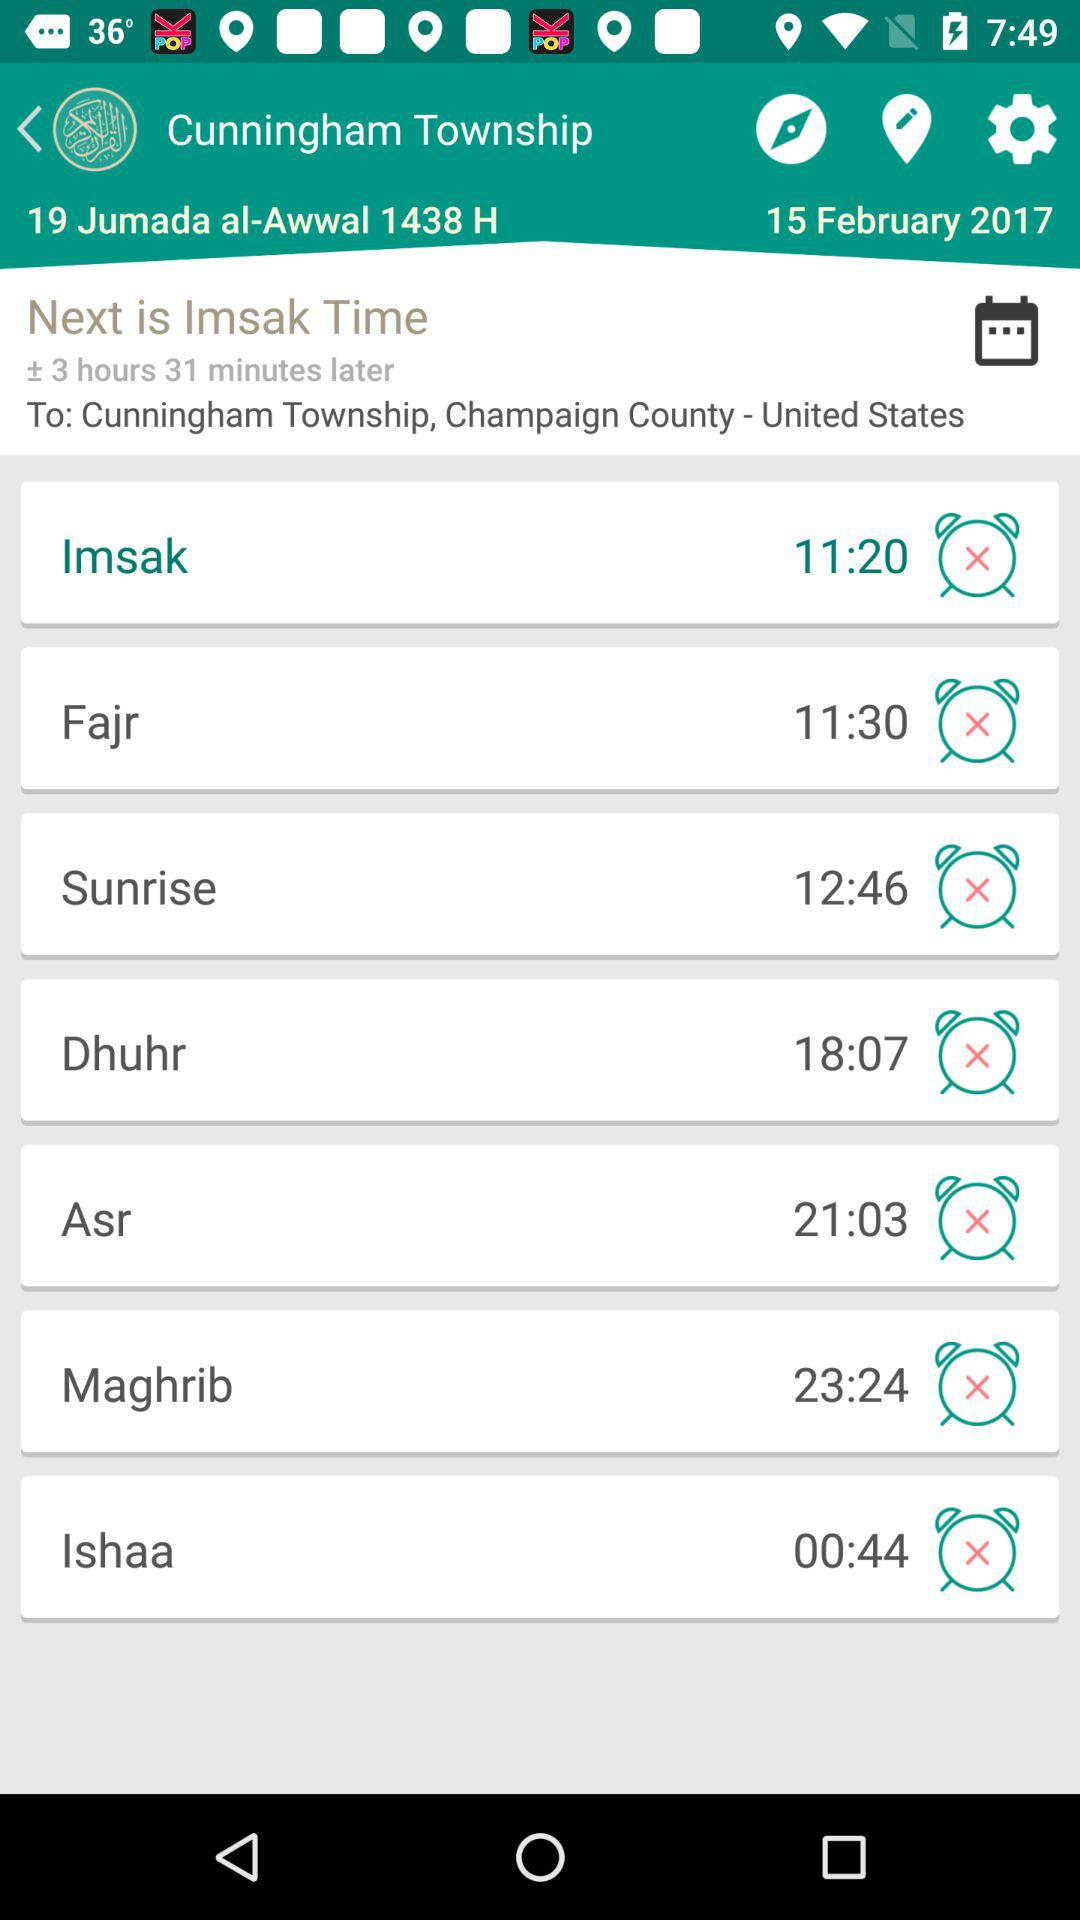What time is shown for "Sunrise"? The time is 12:46. 